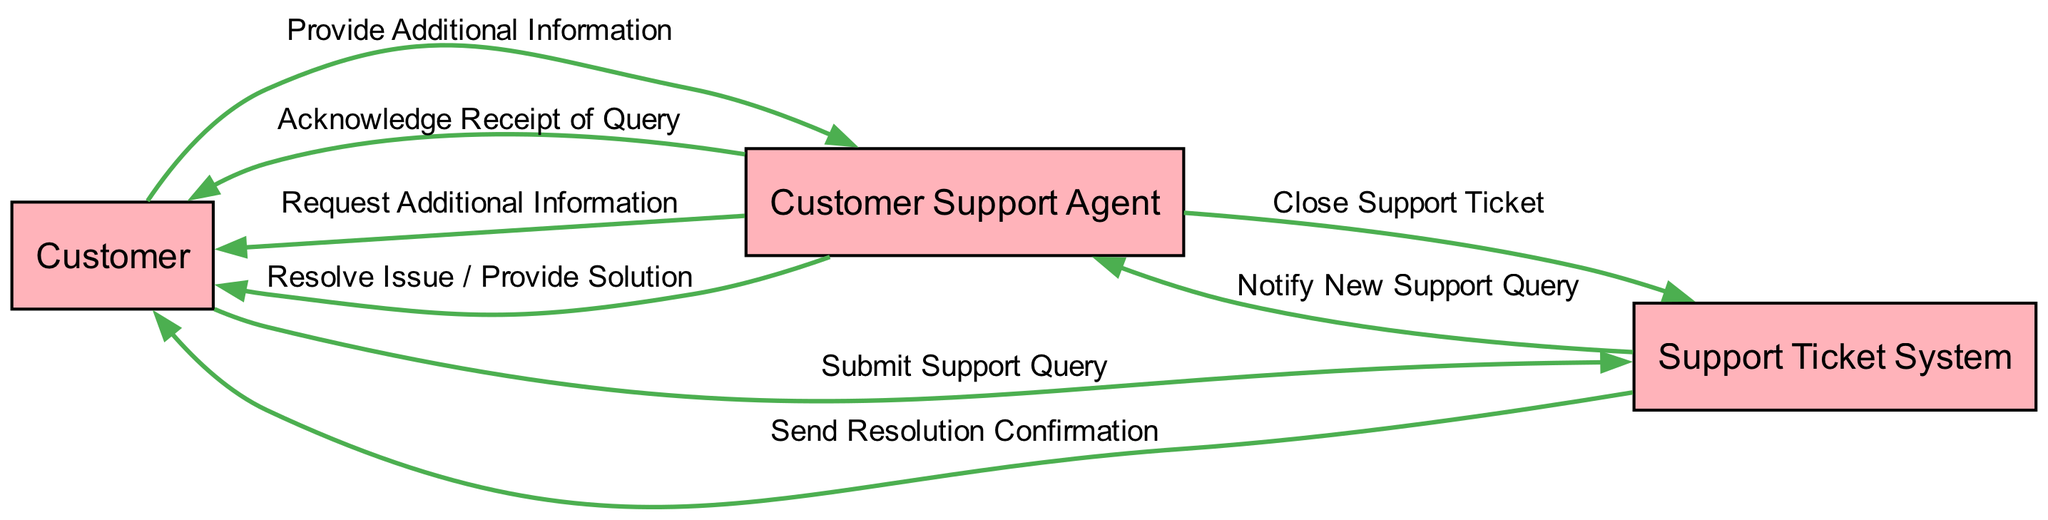What are the actors in the diagram? The actors defined in the diagram are Customer, Customer Support Agent, and Support Ticket System. This can be confirmed by looking at the nodes labeled with these titles within the diagram.
Answer: Customer, Customer Support Agent, Support Ticket System How many actions are represented in the communication flow? To determine the number of actions, count the number of entries in the communicationFlow section of the data. There are eight distinct actions listed, which can be verified by enumerating them in the flow.
Answer: 8 What is the first action in the communication flow? The first action in the flow is "Submit Support Query" initiated by the Customer to the Support Ticket System. This corresponds to the first entry in the provided communication flow list.
Answer: Submit Support Query Which node initiates the action "Request Additional Information"? The action "Request Additional Information" is initiated by the Customer Support Agent. This can be found by identifying the source of this specific action in the communication flow as described in the data.
Answer: Customer Support Agent Who receives the "Send Resolution Confirmation"? The resolution confirmation is sent to the Customer. This conclusion can be drawn by examining the last entry in the communication flow that indicates the direction of communication is from the Support Ticket System to the Customer.
Answer: Customer How many edges connect the Customer to the Customer Support Agent? There are three edges that connect the Customer to the Customer Support Agent. Specifically, these are for the actions: Acknowledge Receipt of Query, Request Additional Information, and Provide Additional Information. Each of these actions establishes a distinct communication link between these two actors.
Answer: 3 What action occurs right after "Notify New Support Query"? The action that occurs right after "Notify New Support Query" is "Acknowledge Receipt of Query," performed by the Customer Support Agent. This can be confirmed by looking at the order of actions in the sequence provided.
Answer: Acknowledge Receipt of Query Which actor is responsible for closing the support ticket? The Customer Support Agent is responsible for closing the support ticket, as indicated by the action "Close Support Ticket" in the communication flow, which is clearly attributed to this actor.
Answer: Customer Support Agent What is the last action taken in the communication flow? The last action taken in the communication flow is "Send Resolution Confirmation." This can be determined by identifying the final entry in the sequence of actions detailed in the data structure, confirming its position as the last communication.
Answer: Send Resolution Confirmation 